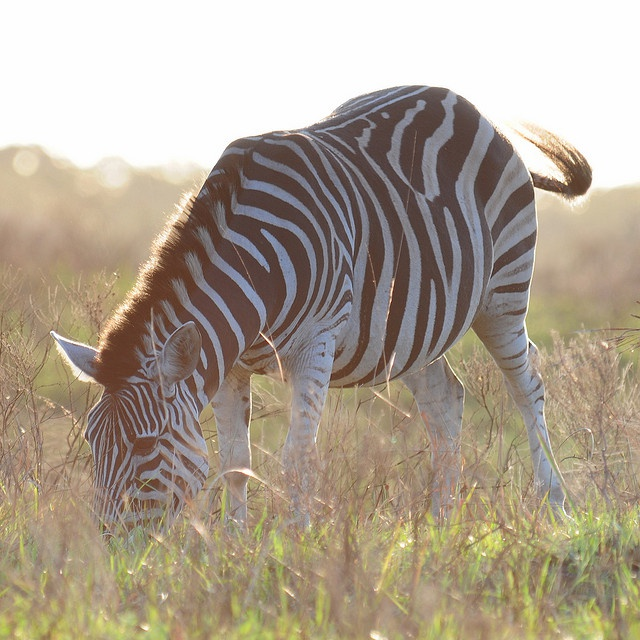Describe the objects in this image and their specific colors. I can see a zebra in white, gray, and maroon tones in this image. 